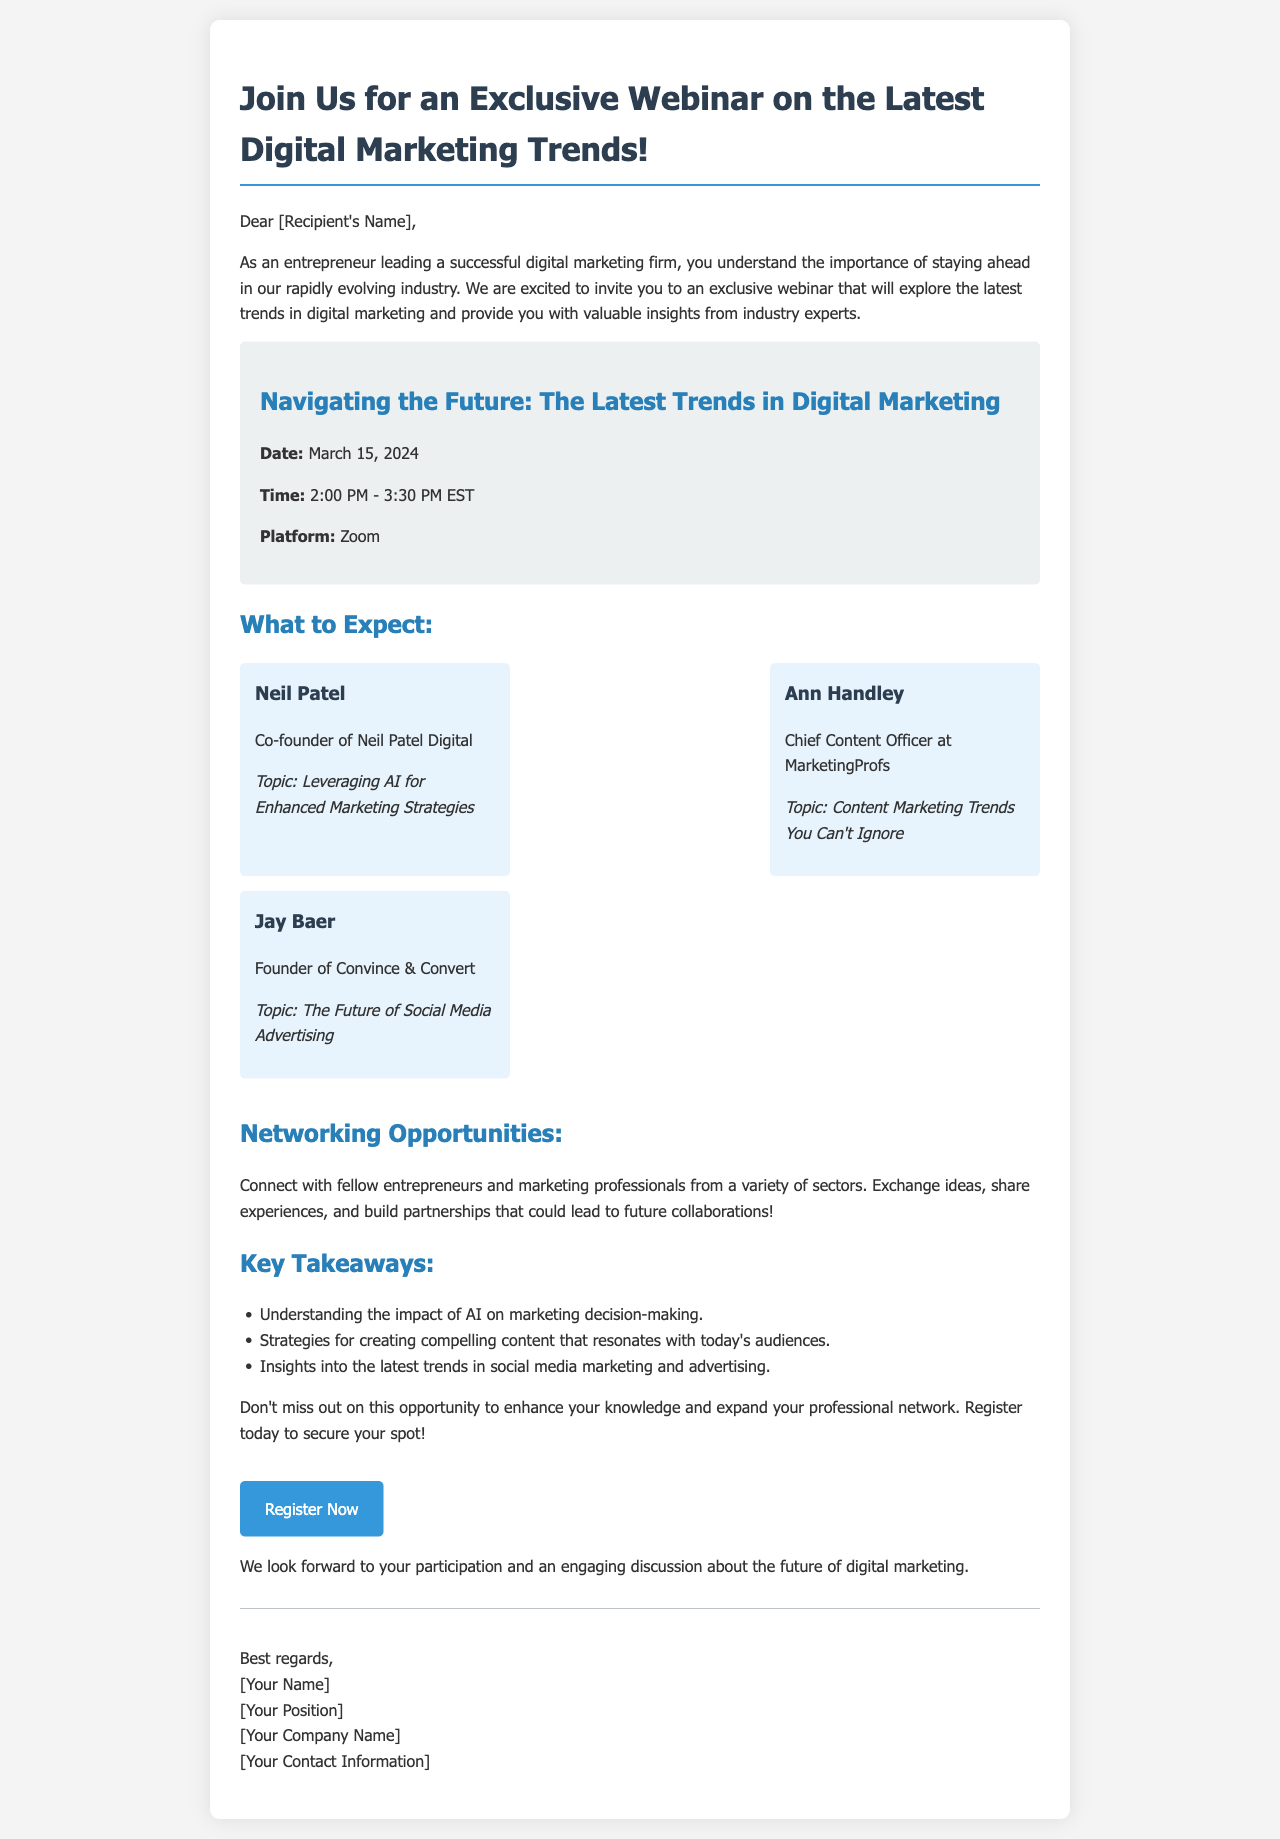What is the title of the webinar? The title of the webinar is listed prominently at the top of the document.
Answer: Navigating the Future: The Latest Trends in Digital Marketing What is the date of the webinar? The date is explicitly mentioned in the webinar details section of the document.
Answer: March 15, 2024 Who is one of the speakers? The names of the speakers are provided in the speaker section, and one can be selected.
Answer: Neil Patel What platform will the webinar be held on? The platform for the webinar is specified in the webinar details section.
Answer: Zoom What time does the webinar start? The time is included in the webinar details section of the document.
Answer: 2:00 PM What is one key takeaway from the webinar? Key takeaways are listed, any one of which can be provided as an answer.
Answer: Understanding the impact of AI on marketing decision-making Who is the Chief Content Officer at MarketingProfs? The position of Chief Content Officer is associated with a specific individual in the document.
Answer: Ann Handley What is the main theme of Jay Baer's talk? The document includes topics assigned to each speaker, indicating what Jay Baer will discuss.
Answer: The Future of Social Media Advertising What type of professionals will participants connect with during the webinar? The document describes the type of individuals who will be part of the networking opportunities.
Answer: Entrepreneurs and marketing professionals 